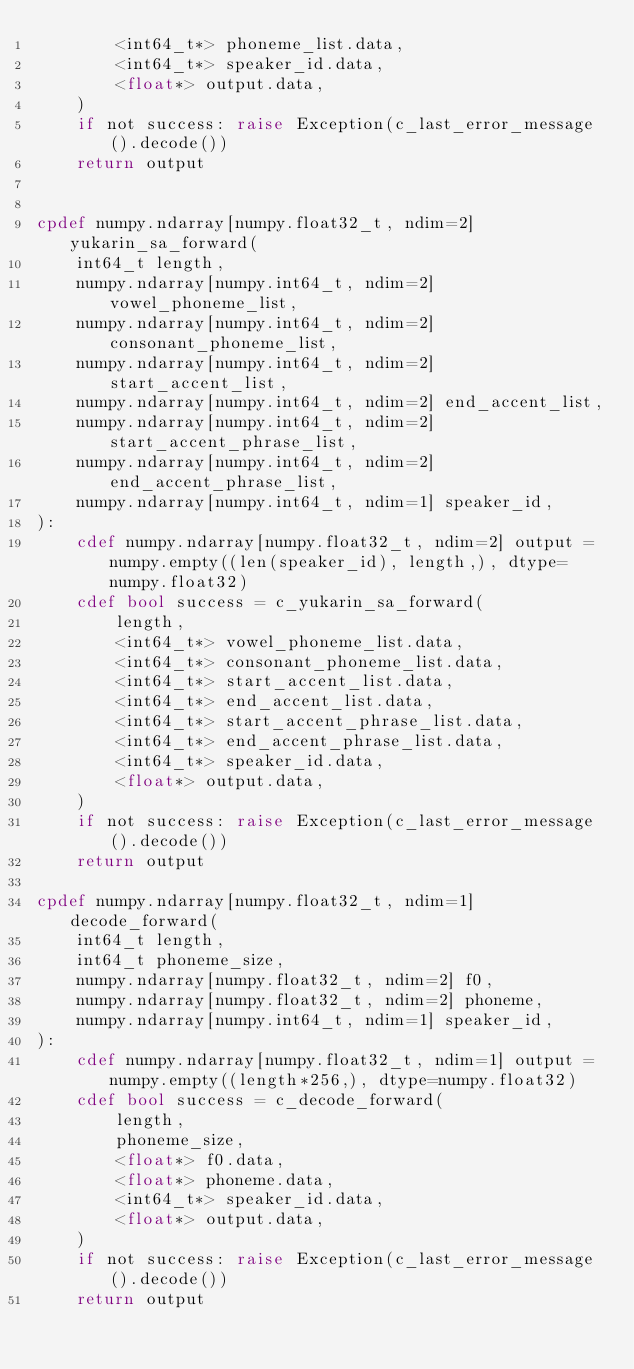<code> <loc_0><loc_0><loc_500><loc_500><_Cython_>        <int64_t*> phoneme_list.data,
        <int64_t*> speaker_id.data,
        <float*> output.data,
    )
    if not success: raise Exception(c_last_error_message().decode())
    return output


cpdef numpy.ndarray[numpy.float32_t, ndim=2] yukarin_sa_forward(
    int64_t length,
    numpy.ndarray[numpy.int64_t, ndim=2] vowel_phoneme_list,
    numpy.ndarray[numpy.int64_t, ndim=2] consonant_phoneme_list,
    numpy.ndarray[numpy.int64_t, ndim=2] start_accent_list,
    numpy.ndarray[numpy.int64_t, ndim=2] end_accent_list,
    numpy.ndarray[numpy.int64_t, ndim=2] start_accent_phrase_list,
    numpy.ndarray[numpy.int64_t, ndim=2] end_accent_phrase_list,
    numpy.ndarray[numpy.int64_t, ndim=1] speaker_id,
):
    cdef numpy.ndarray[numpy.float32_t, ndim=2] output = numpy.empty((len(speaker_id), length,), dtype=numpy.float32)
    cdef bool success = c_yukarin_sa_forward(
        length,
        <int64_t*> vowel_phoneme_list.data,
        <int64_t*> consonant_phoneme_list.data,
        <int64_t*> start_accent_list.data,
        <int64_t*> end_accent_list.data,
        <int64_t*> start_accent_phrase_list.data,
        <int64_t*> end_accent_phrase_list.data,
        <int64_t*> speaker_id.data,
        <float*> output.data,
    )
    if not success: raise Exception(c_last_error_message().decode())
    return output

cpdef numpy.ndarray[numpy.float32_t, ndim=1] decode_forward(
    int64_t length,
    int64_t phoneme_size,
    numpy.ndarray[numpy.float32_t, ndim=2] f0,
    numpy.ndarray[numpy.float32_t, ndim=2] phoneme,
    numpy.ndarray[numpy.int64_t, ndim=1] speaker_id,
):
    cdef numpy.ndarray[numpy.float32_t, ndim=1] output = numpy.empty((length*256,), dtype=numpy.float32)
    cdef bool success = c_decode_forward(
        length,
        phoneme_size,
        <float*> f0.data,
        <float*> phoneme.data,
        <int64_t*> speaker_id.data,
        <float*> output.data,
    )
    if not success: raise Exception(c_last_error_message().decode())
    return output
</code> 